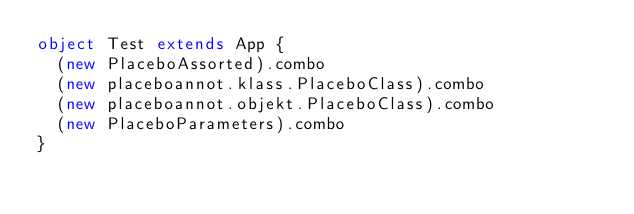<code> <loc_0><loc_0><loc_500><loc_500><_Scala_>object Test extends App {
  (new PlaceboAssorted).combo
  (new placeboannot.klass.PlaceboClass).combo
  (new placeboannot.objekt.PlaceboClass).combo
  (new PlaceboParameters).combo
}
</code> 